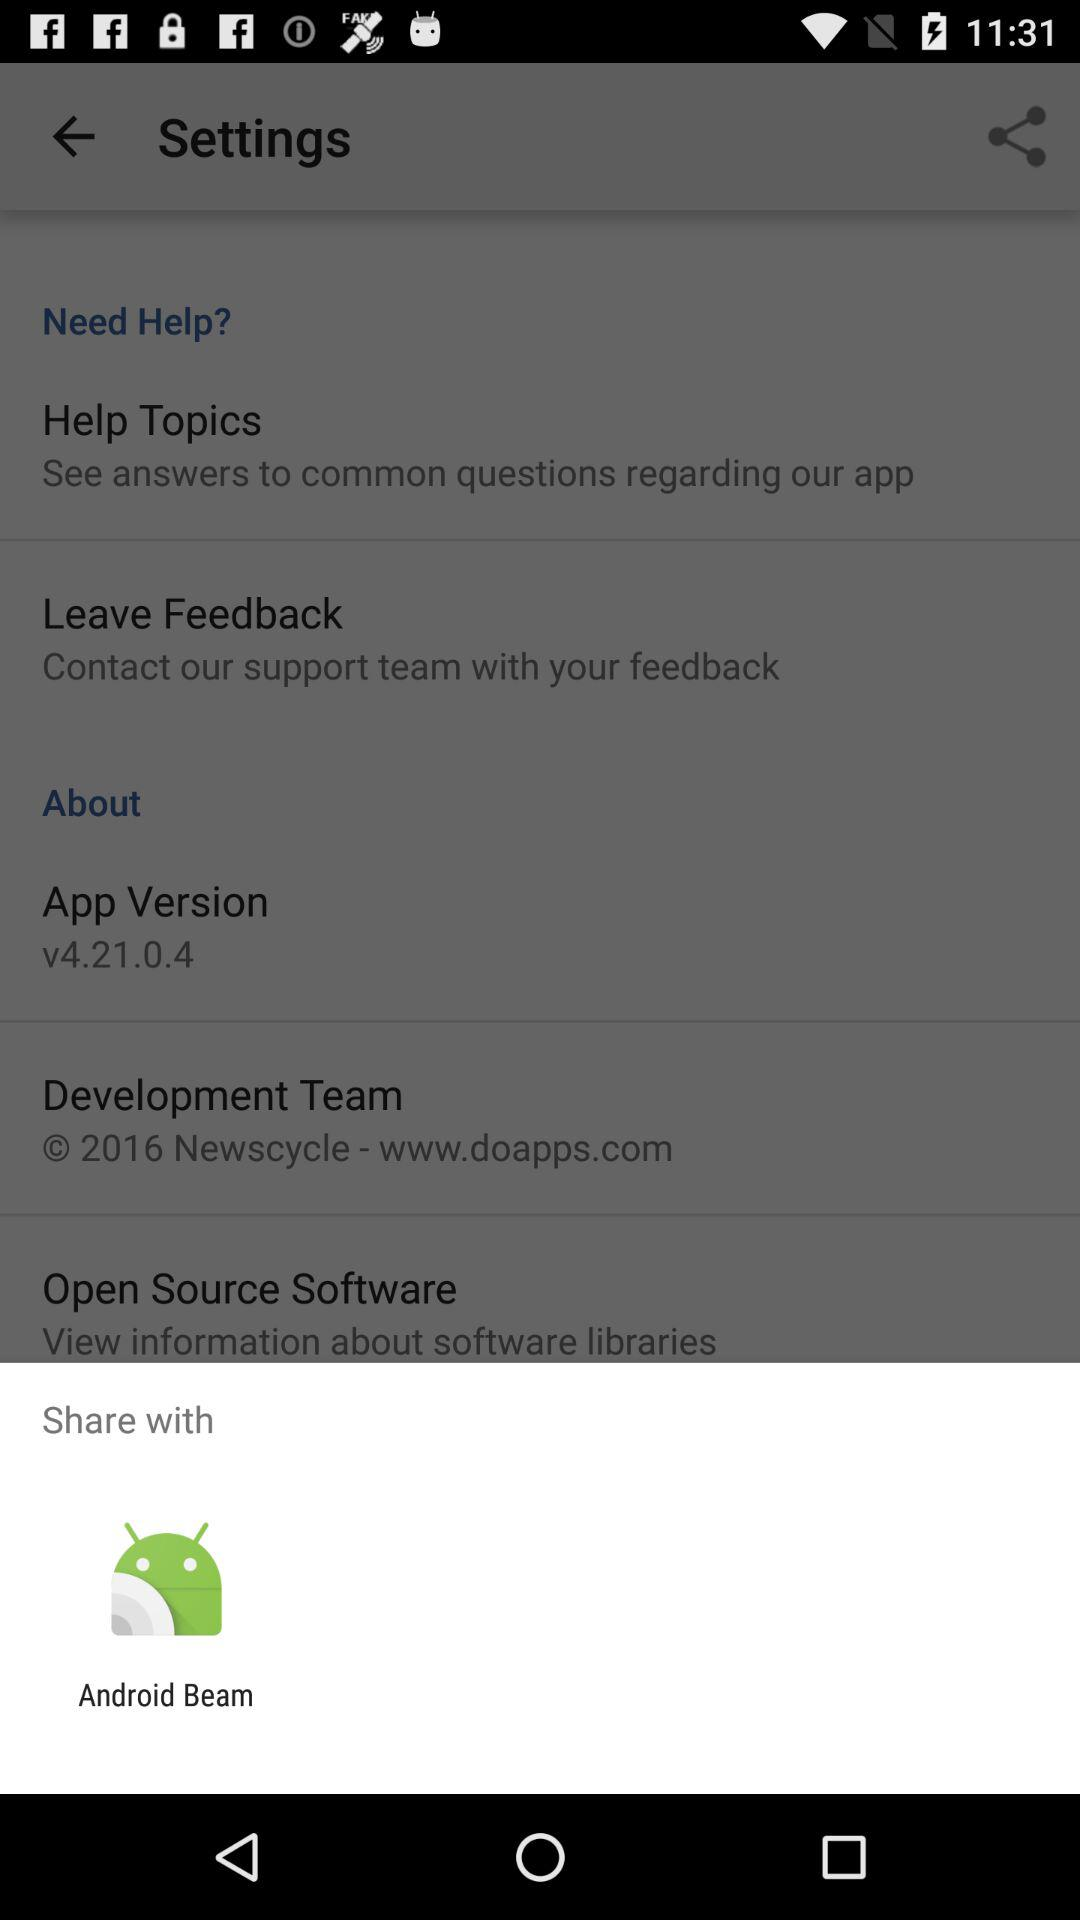Through what app can I share? You can share it with "Android Beam". 